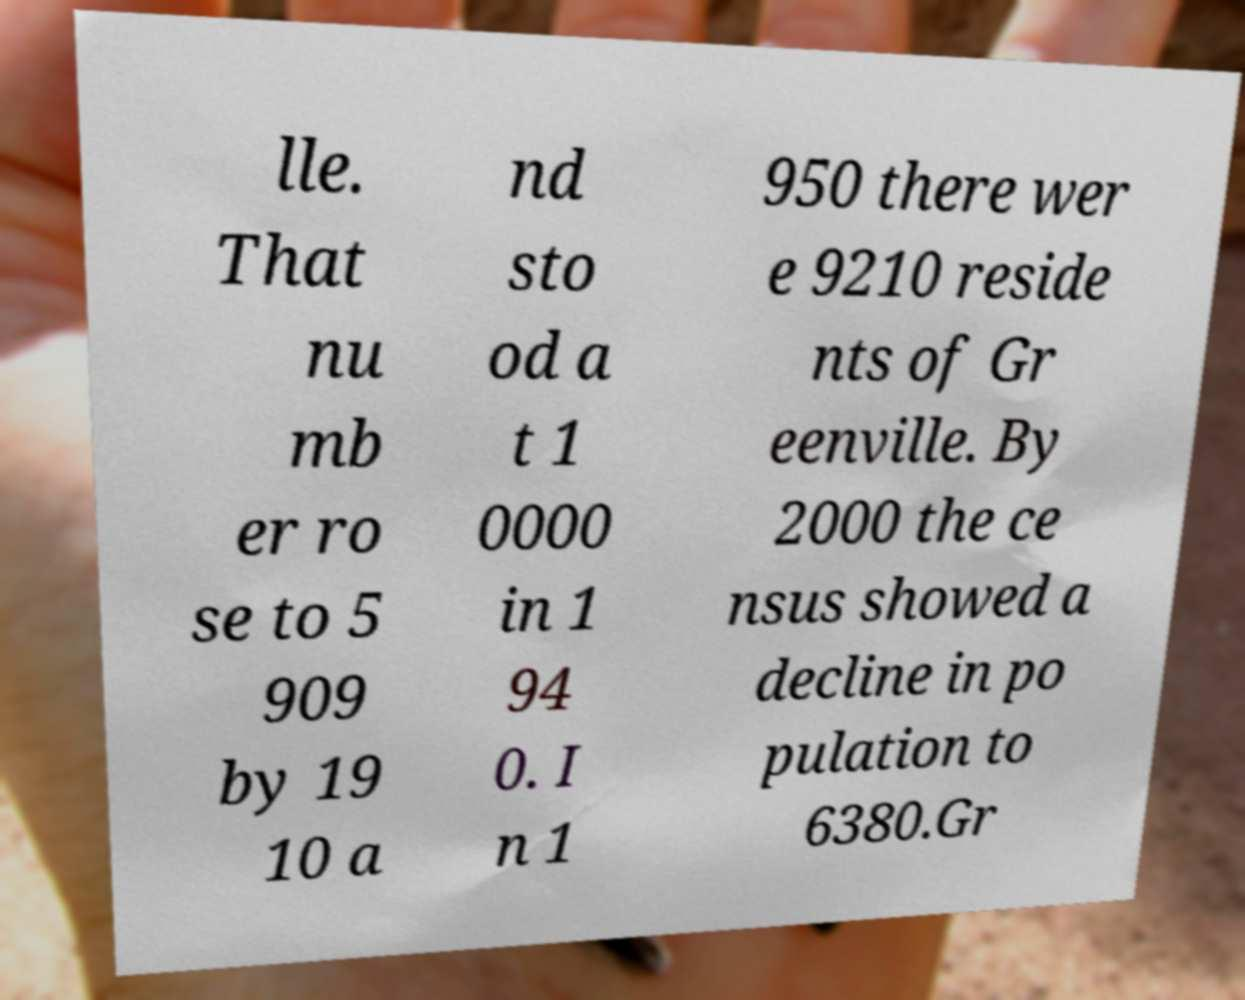Could you extract and type out the text from this image? lle. That nu mb er ro se to 5 909 by 19 10 a nd sto od a t 1 0000 in 1 94 0. I n 1 950 there wer e 9210 reside nts of Gr eenville. By 2000 the ce nsus showed a decline in po pulation to 6380.Gr 